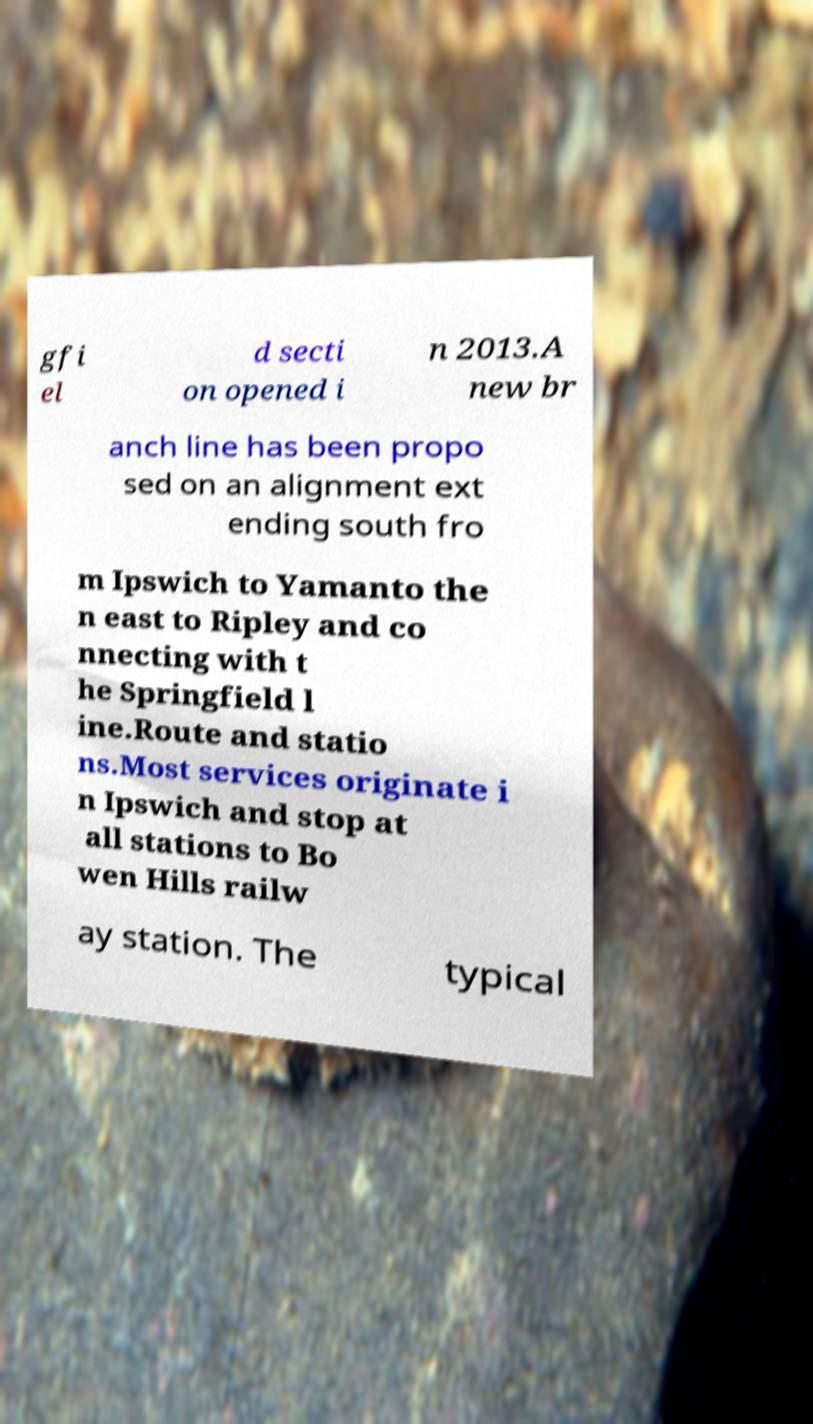There's text embedded in this image that I need extracted. Can you transcribe it verbatim? gfi el d secti on opened i n 2013.A new br anch line has been propo sed on an alignment ext ending south fro m Ipswich to Yamanto the n east to Ripley and co nnecting with t he Springfield l ine.Route and statio ns.Most services originate i n Ipswich and stop at all stations to Bo wen Hills railw ay station. The typical 